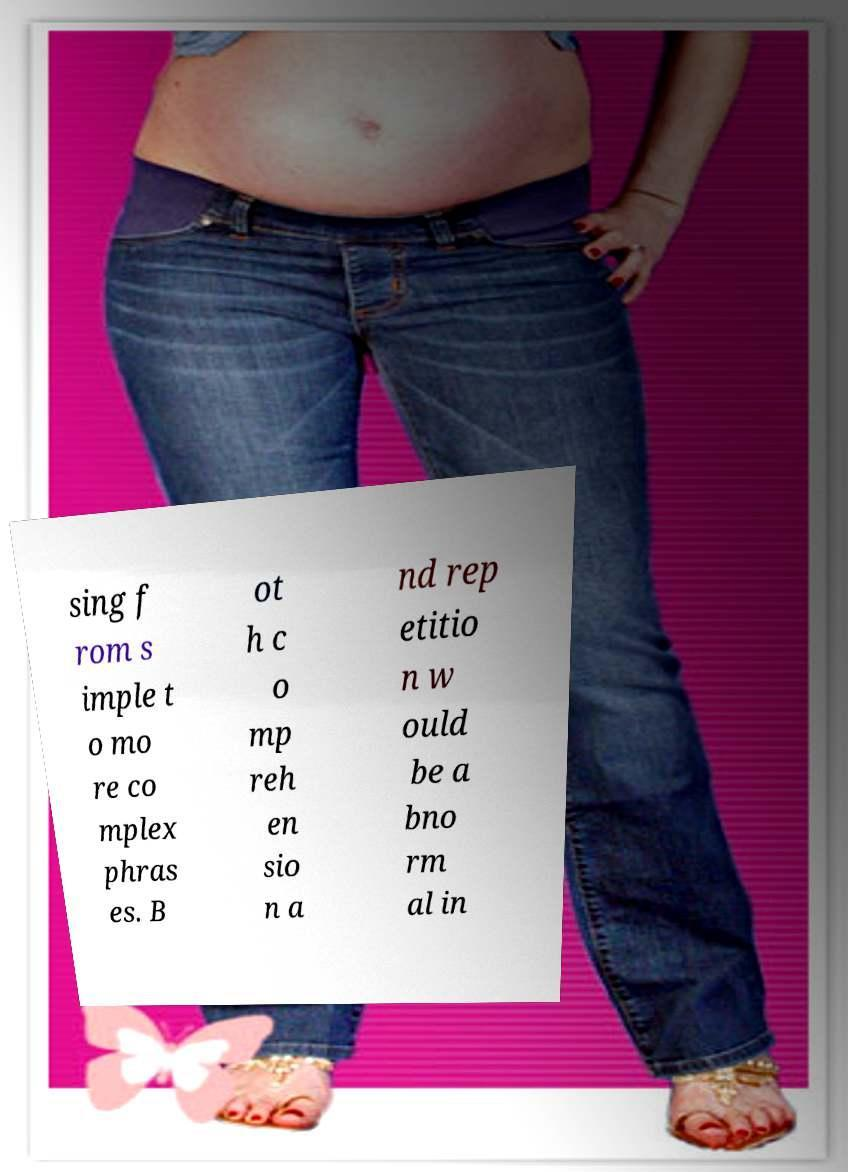Please read and relay the text visible in this image. What does it say? sing f rom s imple t o mo re co mplex phras es. B ot h c o mp reh en sio n a nd rep etitio n w ould be a bno rm al in 